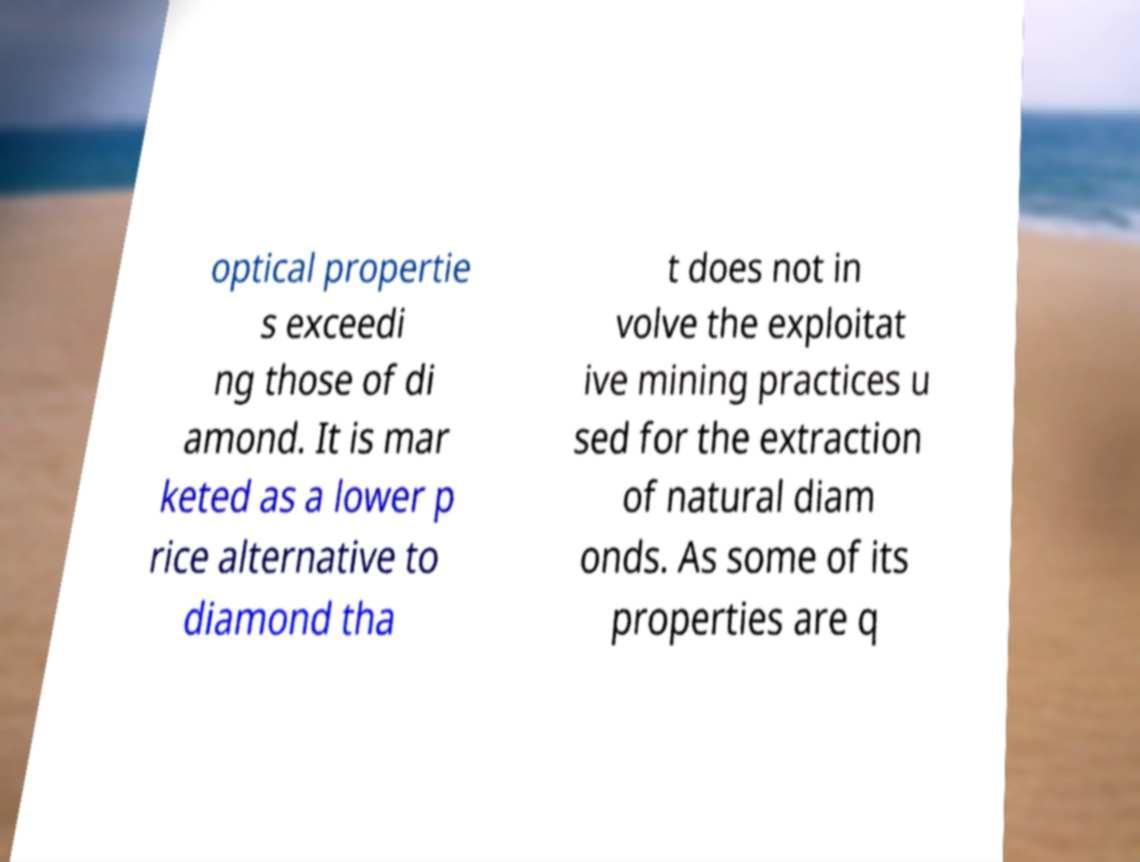Please read and relay the text visible in this image. What does it say? optical propertie s exceedi ng those of di amond. It is mar keted as a lower p rice alternative to diamond tha t does not in volve the exploitat ive mining practices u sed for the extraction of natural diam onds. As some of its properties are q 